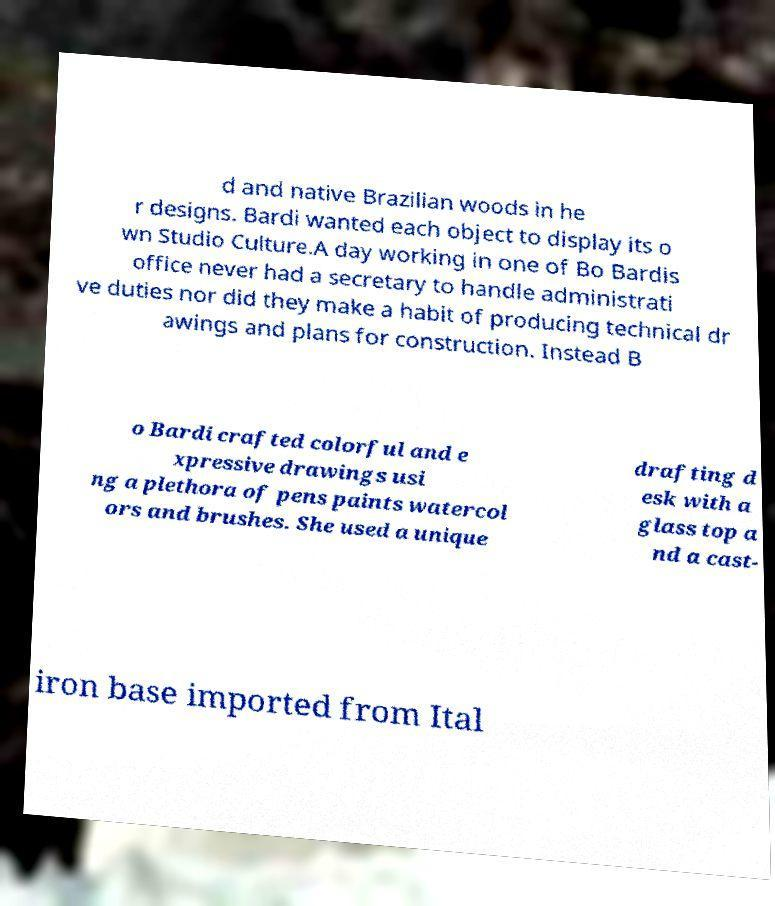Please identify and transcribe the text found in this image. d and native Brazilian woods in he r designs. Bardi wanted each object to display its o wn Studio Culture.A day working in one of Bo Bardis office never had a secretary to handle administrati ve duties nor did they make a habit of producing technical dr awings and plans for construction. Instead B o Bardi crafted colorful and e xpressive drawings usi ng a plethora of pens paints watercol ors and brushes. She used a unique drafting d esk with a glass top a nd a cast- iron base imported from Ital 